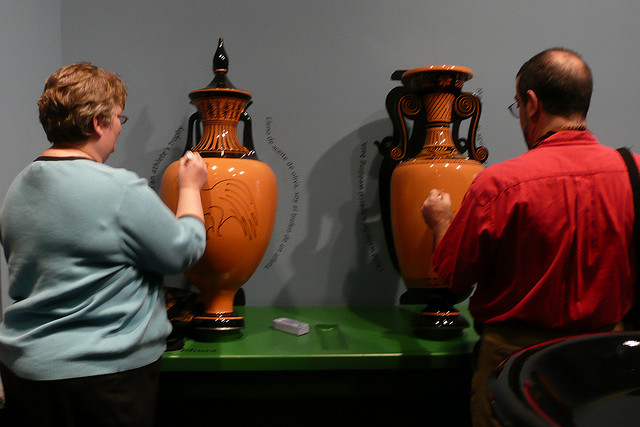<image>What is in the vase? I am not sure what is in the vase. It might be nothing or something else like ashes. What language is the writing on the pot? It is ambiguous which language is written on the pot as there are varying responses of 'none', 'english', 'chinese', 'arabic' and 'greek'. Is there water in the vase? There is no water in the vase. What animal appears on both vases? I am not sure about it. It can be seen as 'chicken', 'turkey', 'rooster' or 'bird'. What is in the vase? I am not sure what is in the vase. It is possible that there is nothing inside. What language is the writing on the pot? I am not sure what language is the writing on the pot. It can be seen in Chinese, English, Arabic or Greek. Is there water in the vase? There is no water in the vase. What animal appears on both vases? I don't know which animal appears on both vases. It can be either a chicken or a rooster. 